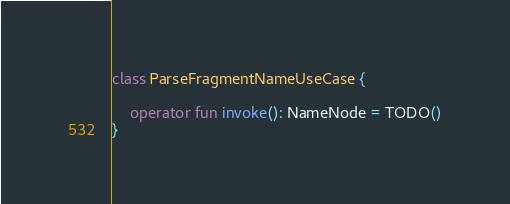<code> <loc_0><loc_0><loc_500><loc_500><_Kotlin_>
class ParseFragmentNameUseCase {

    operator fun invoke(): NameNode = TODO()
}</code> 